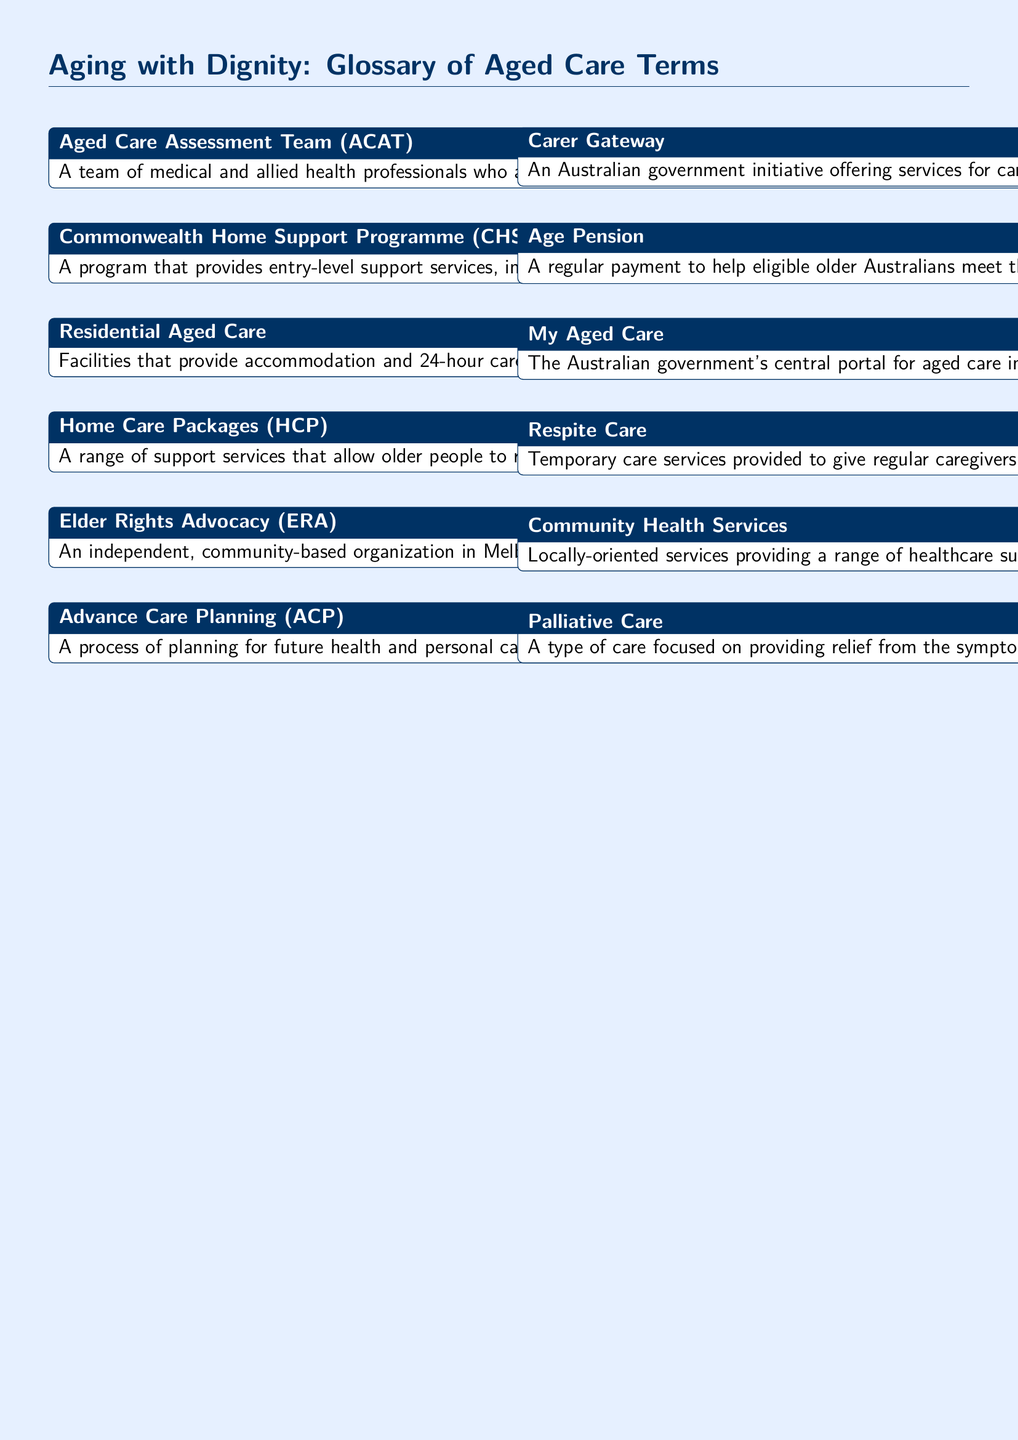what does ACAT stand for? ACAT stands for Aged Care Assessment Team, a group that assesses older people's needs.
Answer: Aged Care Assessment Team what is respite care? Respite care refers to temporary care services provided for caregivers to take a break.
Answer: Temporary care services who provides Home Care Packages in Melbourne? Providers mentioned for Home Care Packages in Melbourne include Bolton Clarke and Benetas.
Answer: Bolton Clarke and Benetas what is the Age Pension? The Age Pension is a regular payment to help eligible older Australians meet living costs.
Answer: Regular payment what is the role of Elder Rights Advocacy? Elder Rights Advocacy provides advocacy and support services related to older people's rights in aged care.
Answer: Advocacy and support services how many levels are there for Home Care Packages? Home Care Packages are categorized into four levels based on care complexity.
Answer: Four levels what is the purpose of Palliative Care? Palliative Care aims to provide relief from symptoms and improve the quality of life.
Answer: Improve quality of life what is My Aged Care? My Aged Care is the Australian government's portal for aged care information and referrals.
Answer: Central portal what type of program is CHSP? CHSP stands for Commonwealth Home Support Programme, offering entry-level support services for seniors.
Answer: Entry-level support services how does the Carer Gateway help carers? The Carer Gateway offers various services, including counseling and respite care to support carers.
Answer: Counseling and respite care 